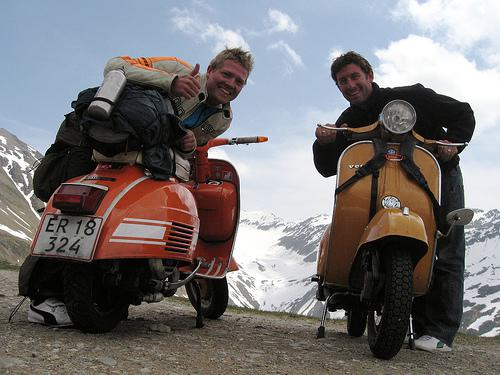Can you describe the two people in the photo? Sure, there are two individuals posing next to the motorbikes. The person on the left is smiling, wearing an orange jacket with a backpack, while the person on the right is also smiling and wearing a dark jacket. Both appear to be enjoying their time in this scenic location. 